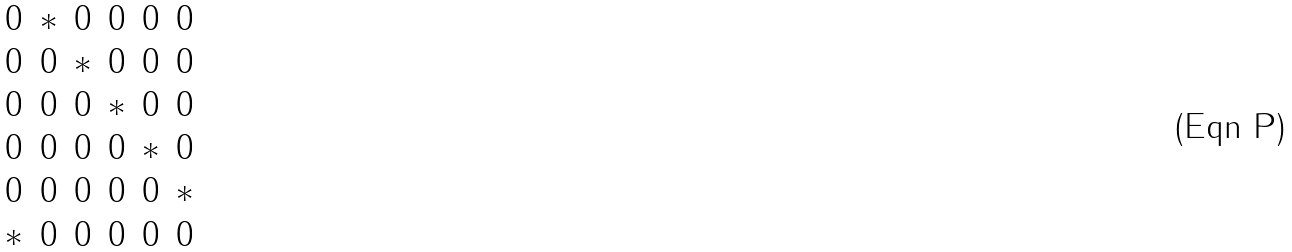<formula> <loc_0><loc_0><loc_500><loc_500>\begin{matrix} 0 & * & 0 & 0 & 0 & 0 \\ 0 & 0 & * & 0 & 0 & 0 \\ 0 & 0 & 0 & * & 0 & 0 \\ 0 & 0 & 0 & 0 & * & 0 \\ 0 & 0 & 0 & 0 & 0 & * \\ * & 0 & 0 & 0 & 0 & 0 \end{matrix}</formula> 